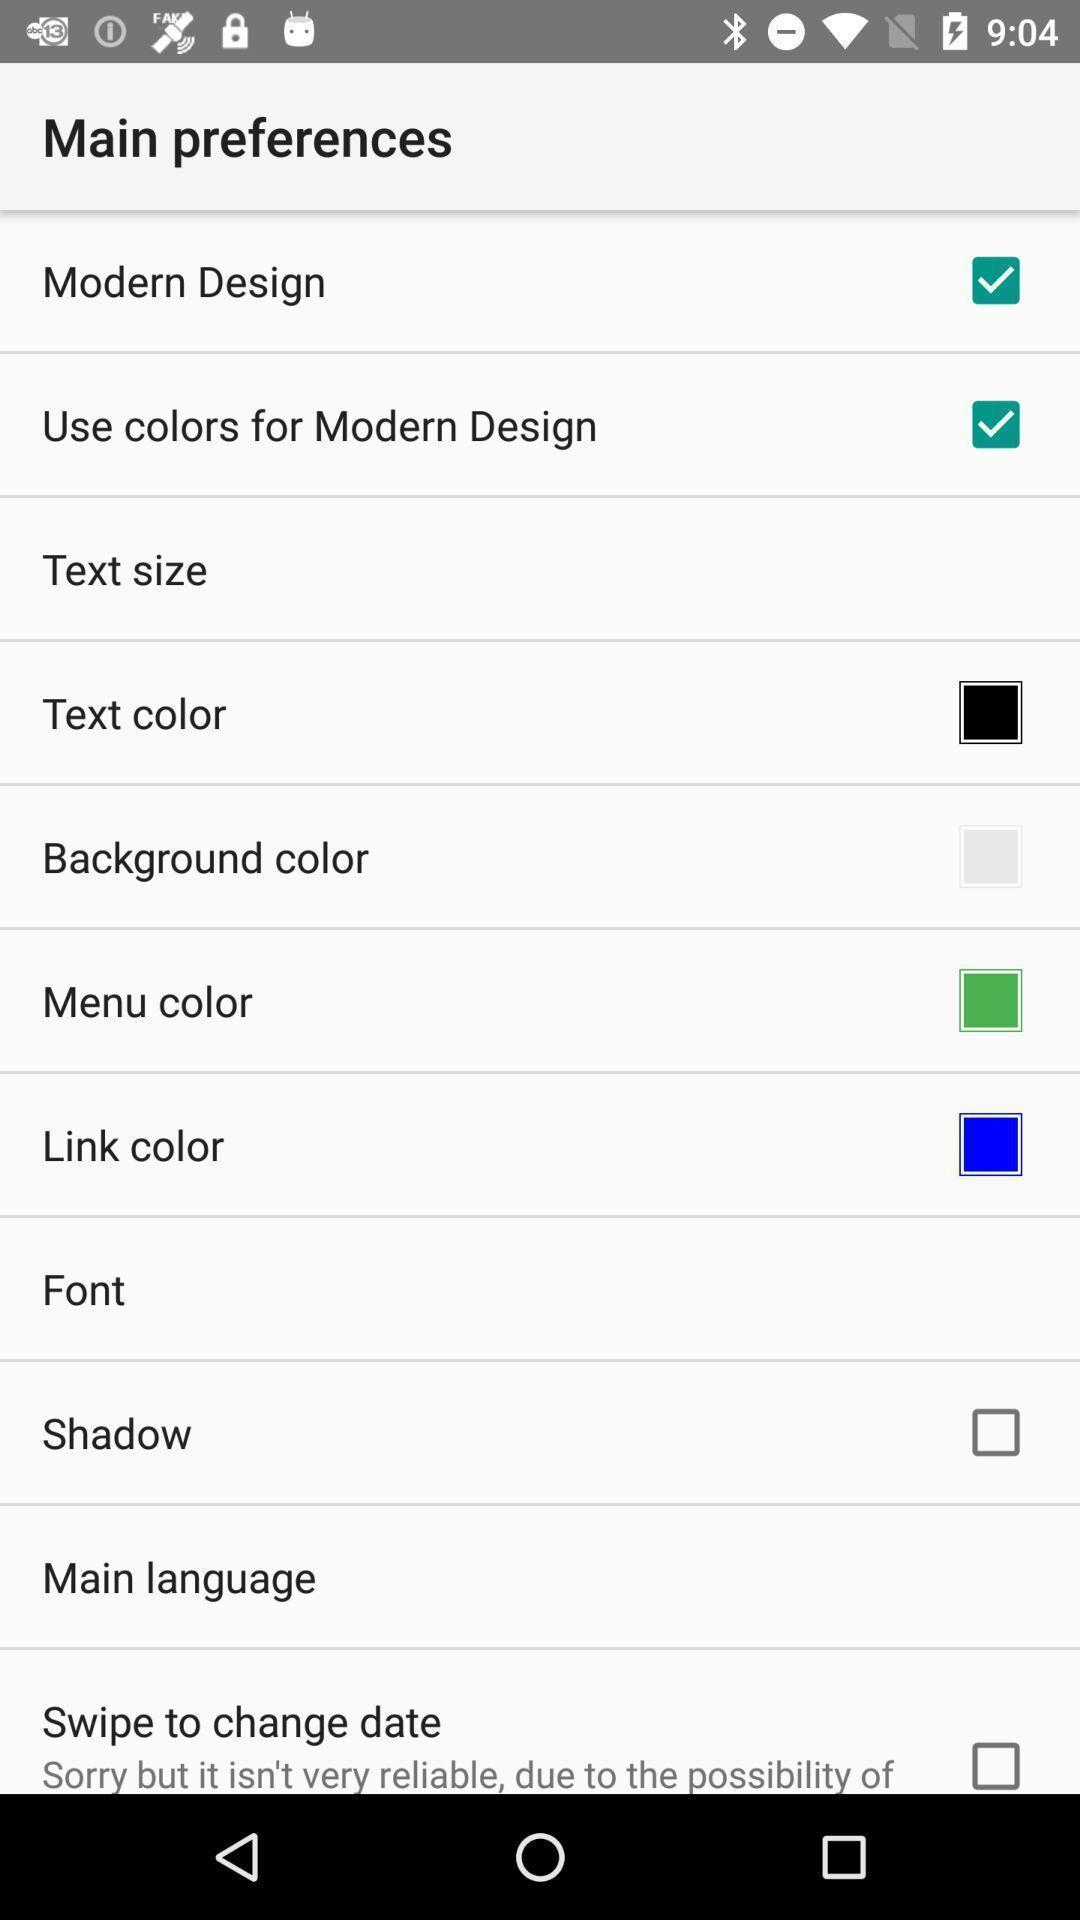Explain the elements present in this screenshot. Preferences settings showing in application. 